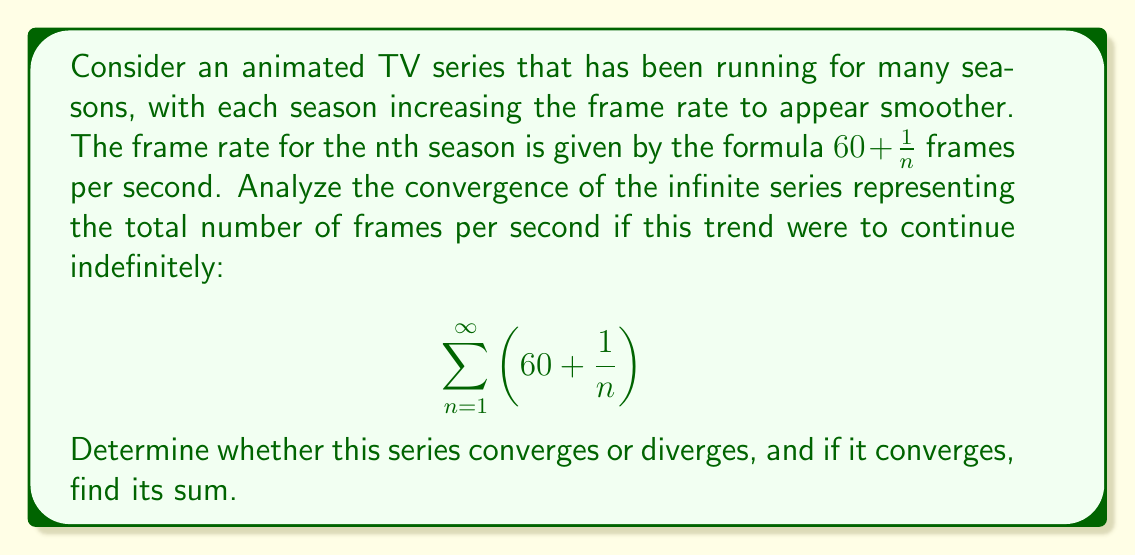Can you answer this question? Let's approach this step-by-step:

1) First, let's rewrite the series:

   $$\sum_{n=1}^{\infty} \left(60 + \frac{1}{n}\right) = 60\sum_{n=1}^{\infty} 1 + \sum_{n=1}^{\infty} \frac{1}{n}$$

2) We can see that this is the sum of two series:
   
   Series 1: $60\sum_{n=1}^{\infty} 1$
   Series 2: $\sum_{n=1}^{\infty} \frac{1}{n}$

3) Let's analyze each series:

   Series 1: This is a constant series. $\sum_{n=1}^{\infty} 1 = \infty$, so $60\sum_{n=1}^{\infty} 1 = 60 \cdot \infty = \infty$

   Series 2: This is the harmonic series, which is known to diverge.

4) Since both series diverge, their sum must also diverge.

5) Interpretation: This divergence suggests that if the TV series were to continue indefinitely with this frame rate increase pattern, the cumulative frame rate would grow without bound. This is analogous to how a TV series that runs for too many seasons often loses quality and becomes overextended.
Answer: The series diverges. 